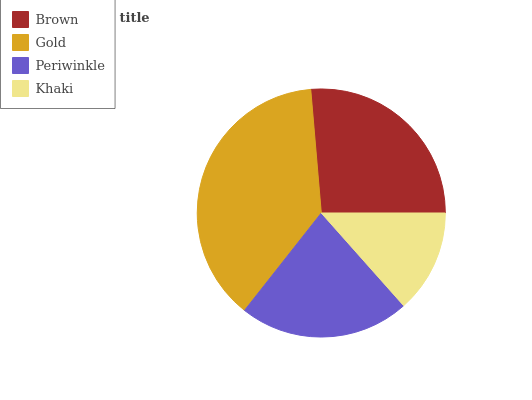Is Khaki the minimum?
Answer yes or no. Yes. Is Gold the maximum?
Answer yes or no. Yes. Is Periwinkle the minimum?
Answer yes or no. No. Is Periwinkle the maximum?
Answer yes or no. No. Is Gold greater than Periwinkle?
Answer yes or no. Yes. Is Periwinkle less than Gold?
Answer yes or no. Yes. Is Periwinkle greater than Gold?
Answer yes or no. No. Is Gold less than Periwinkle?
Answer yes or no. No. Is Brown the high median?
Answer yes or no. Yes. Is Periwinkle the low median?
Answer yes or no. Yes. Is Khaki the high median?
Answer yes or no. No. Is Brown the low median?
Answer yes or no. No. 